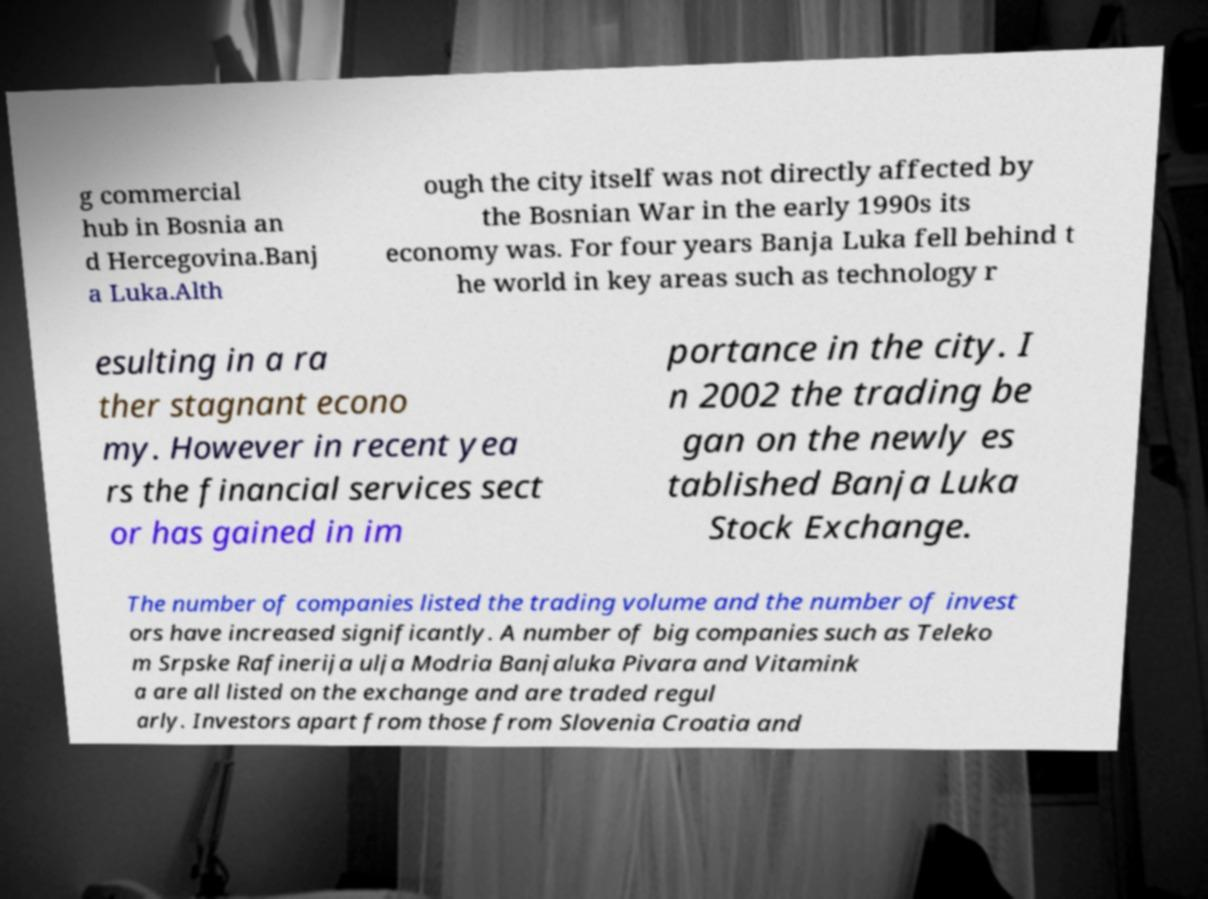Could you assist in decoding the text presented in this image and type it out clearly? g commercial hub in Bosnia an d Hercegovina.Banj a Luka.Alth ough the city itself was not directly affected by the Bosnian War in the early 1990s its economy was. For four years Banja Luka fell behind t he world in key areas such as technology r esulting in a ra ther stagnant econo my. However in recent yea rs the financial services sect or has gained in im portance in the city. I n 2002 the trading be gan on the newly es tablished Banja Luka Stock Exchange. The number of companies listed the trading volume and the number of invest ors have increased significantly. A number of big companies such as Teleko m Srpske Rafinerija ulja Modria Banjaluka Pivara and Vitamink a are all listed on the exchange and are traded regul arly. Investors apart from those from Slovenia Croatia and 